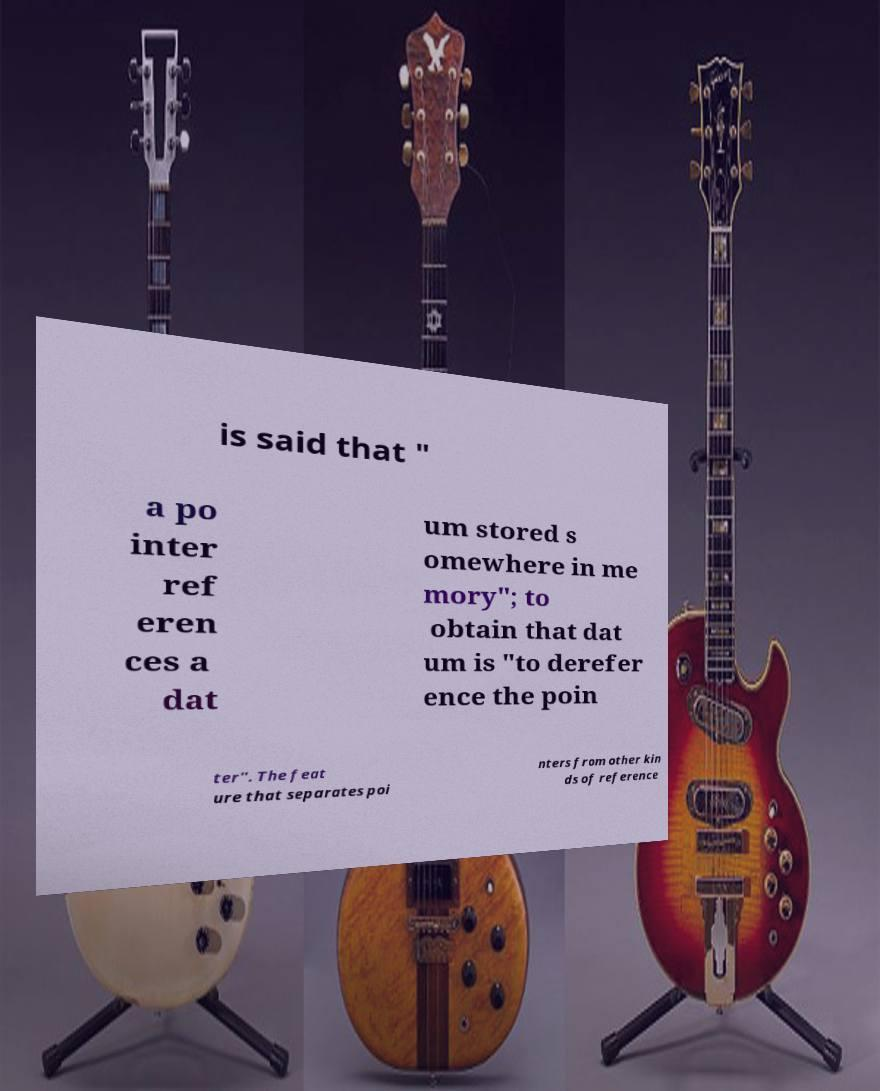What messages or text are displayed in this image? I need them in a readable, typed format. is said that " a po inter ref eren ces a dat um stored s omewhere in me mory"; to obtain that dat um is "to derefer ence the poin ter". The feat ure that separates poi nters from other kin ds of reference 